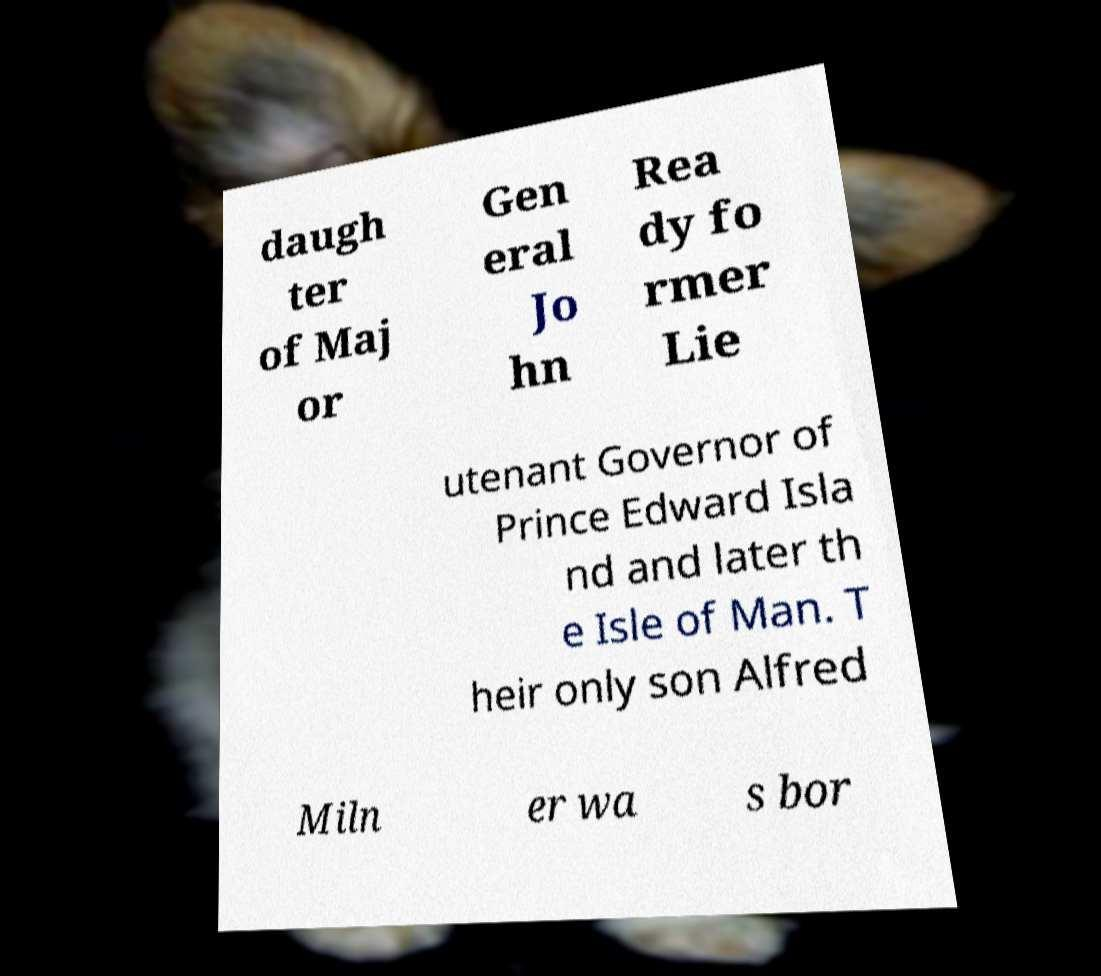Please identify and transcribe the text found in this image. daugh ter of Maj or Gen eral Jo hn Rea dy fo rmer Lie utenant Governor of Prince Edward Isla nd and later th e Isle of Man. T heir only son Alfred Miln er wa s bor 